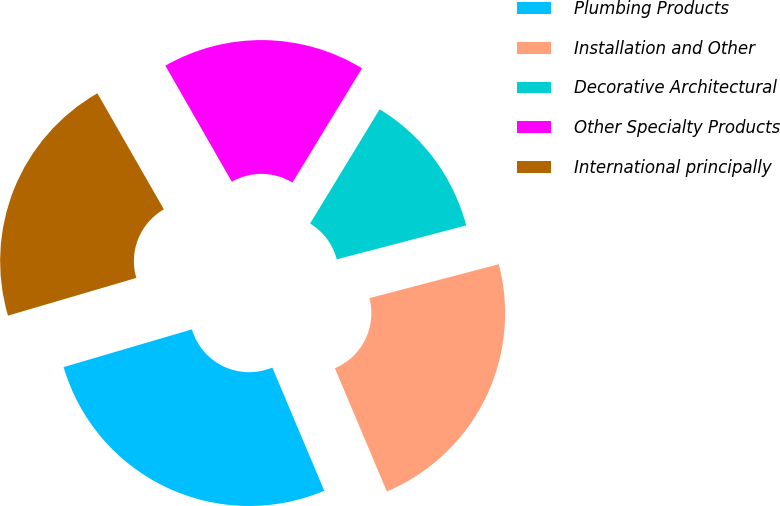<chart> <loc_0><loc_0><loc_500><loc_500><pie_chart><fcel>Plumbing Products<fcel>Installation and Other<fcel>Decorative Architectural<fcel>Other Specialty Products<fcel>International principally<nl><fcel>26.8%<fcel>22.73%<fcel>12.22%<fcel>16.98%<fcel>21.27%<nl></chart> 